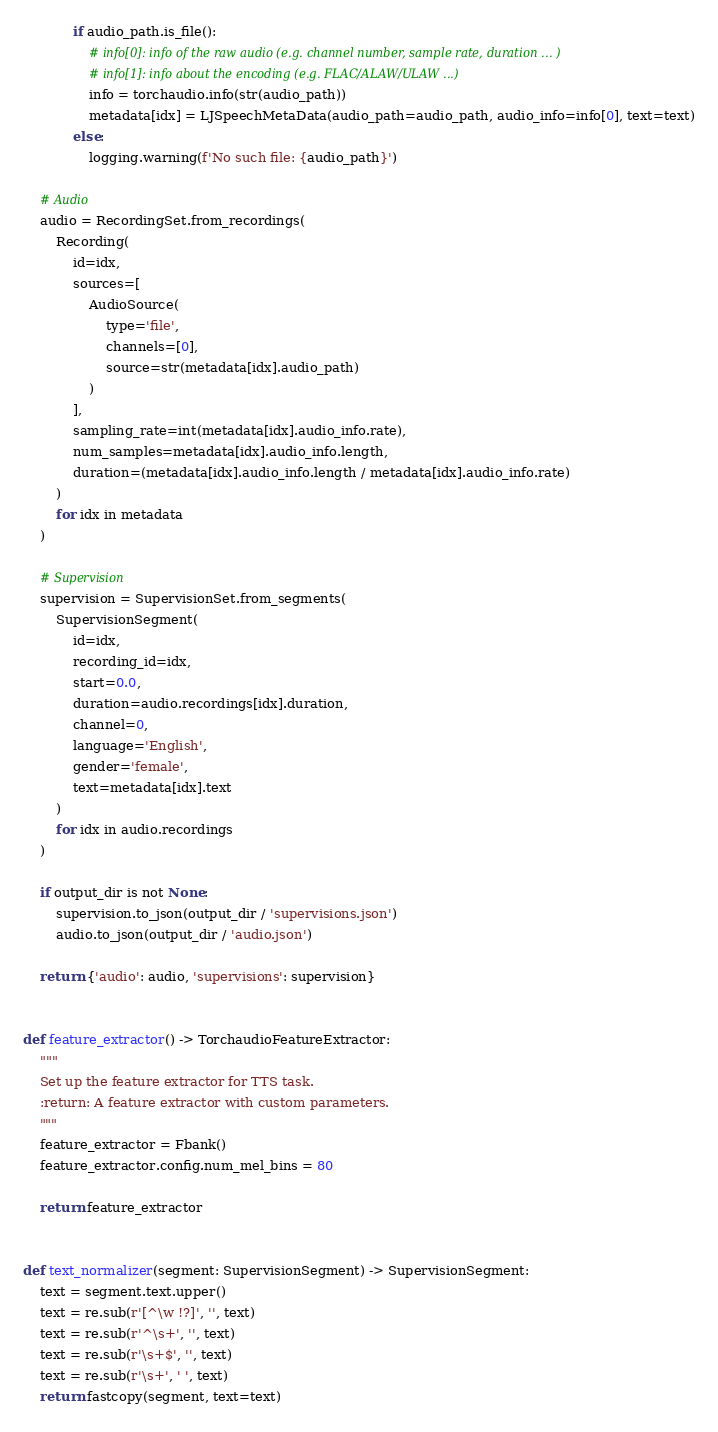<code> <loc_0><loc_0><loc_500><loc_500><_Python_>            if audio_path.is_file():
                # info[0]: info of the raw audio (e.g. channel number, sample rate, duration ... )
                # info[1]: info about the encoding (e.g. FLAC/ALAW/ULAW ...)
                info = torchaudio.info(str(audio_path))
                metadata[idx] = LJSpeechMetaData(audio_path=audio_path, audio_info=info[0], text=text)
            else:
                logging.warning(f'No such file: {audio_path}')

    # Audio
    audio = RecordingSet.from_recordings(
        Recording(
            id=idx,
            sources=[
                AudioSource(
                    type='file',
                    channels=[0],
                    source=str(metadata[idx].audio_path)
                )
            ],
            sampling_rate=int(metadata[idx].audio_info.rate),
            num_samples=metadata[idx].audio_info.length,
            duration=(metadata[idx].audio_info.length / metadata[idx].audio_info.rate)
        )
        for idx in metadata
    )

    # Supervision
    supervision = SupervisionSet.from_segments(
        SupervisionSegment(
            id=idx,
            recording_id=idx,
            start=0.0,
            duration=audio.recordings[idx].duration,
            channel=0,
            language='English',
            gender='female',
            text=metadata[idx].text
        )
        for idx in audio.recordings
    )

    if output_dir is not None:
        supervision.to_json(output_dir / 'supervisions.json')
        audio.to_json(output_dir / 'audio.json')

    return {'audio': audio, 'supervisions': supervision}


def feature_extractor() -> TorchaudioFeatureExtractor:
    """
    Set up the feature extractor for TTS task.
    :return: A feature extractor with custom parameters.
    """
    feature_extractor = Fbank()
    feature_extractor.config.num_mel_bins = 80

    return feature_extractor


def text_normalizer(segment: SupervisionSegment) -> SupervisionSegment:
    text = segment.text.upper()
    text = re.sub(r'[^\w !?]', '', text)
    text = re.sub(r'^\s+', '', text)
    text = re.sub(r'\s+$', '', text)
    text = re.sub(r'\s+', ' ', text)
    return fastcopy(segment, text=text)
</code> 